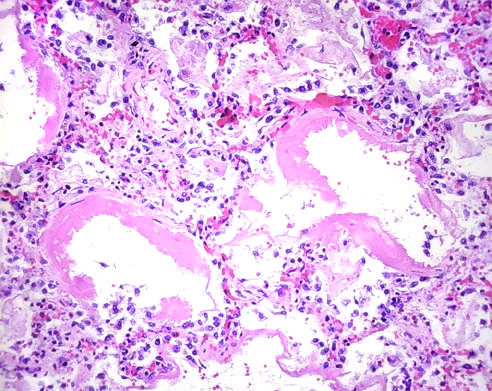what are distended?
Answer the question using a single word or phrase. Other alveoli 